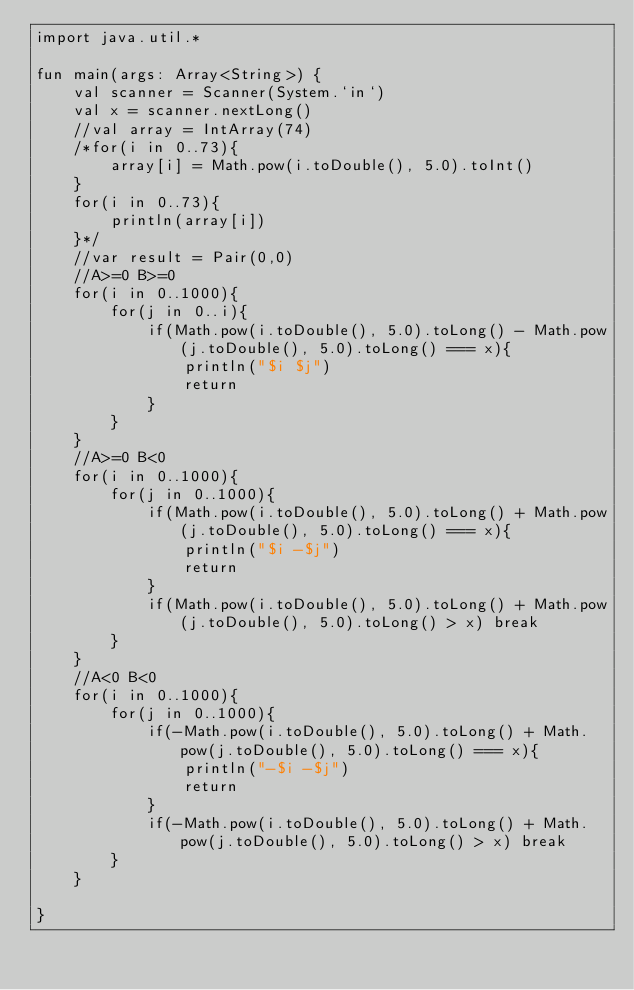<code> <loc_0><loc_0><loc_500><loc_500><_Kotlin_>import java.util.*

fun main(args: Array<String>) {
    val scanner = Scanner(System.`in`)
    val x = scanner.nextLong()
    //val array = IntArray(74)
    /*for(i in 0..73){
        array[i] = Math.pow(i.toDouble(), 5.0).toInt()
    }
    for(i in 0..73){
        println(array[i])
    }*/
    //var result = Pair(0,0)
    //A>=0 B>=0
    for(i in 0..1000){
        for(j in 0..i){
            if(Math.pow(i.toDouble(), 5.0).toLong() - Math.pow(j.toDouble(), 5.0).toLong() === x){
                println("$i $j")
                return
            }
        }
    }
    //A>=0 B<0
    for(i in 0..1000){
        for(j in 0..1000){
            if(Math.pow(i.toDouble(), 5.0).toLong() + Math.pow(j.toDouble(), 5.0).toLong() === x){
                println("$i -$j")
                return
            }
            if(Math.pow(i.toDouble(), 5.0).toLong() + Math.pow(j.toDouble(), 5.0).toLong() > x) break
        }
    }
    //A<0 B<0
    for(i in 0..1000){
        for(j in 0..1000){
            if(-Math.pow(i.toDouble(), 5.0).toLong() + Math.pow(j.toDouble(), 5.0).toLong() === x){
                println("-$i -$j")
                return
            }
            if(-Math.pow(i.toDouble(), 5.0).toLong() + Math.pow(j.toDouble(), 5.0).toLong() > x) break
        }
    }

}</code> 